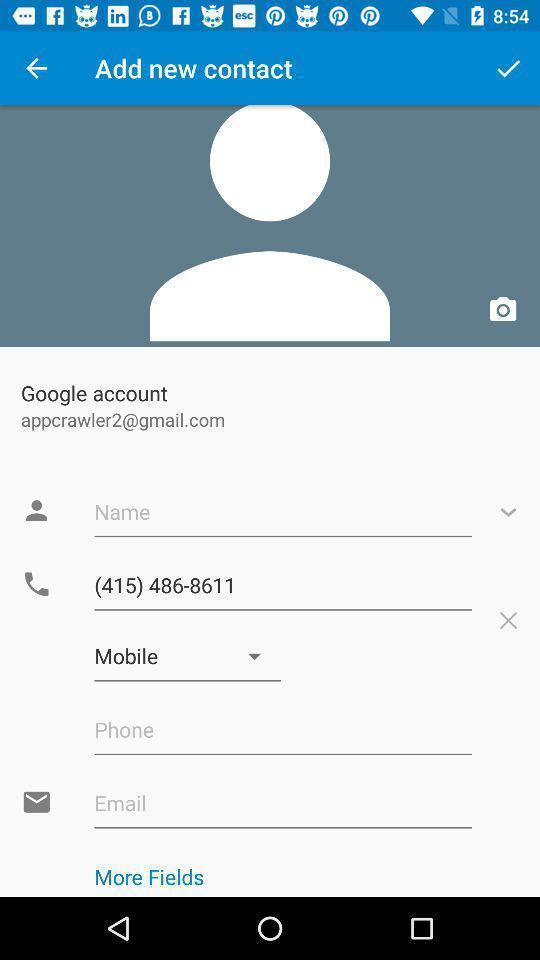Explain what's happening in this screen capture. Page displaying to enter details in profile. 